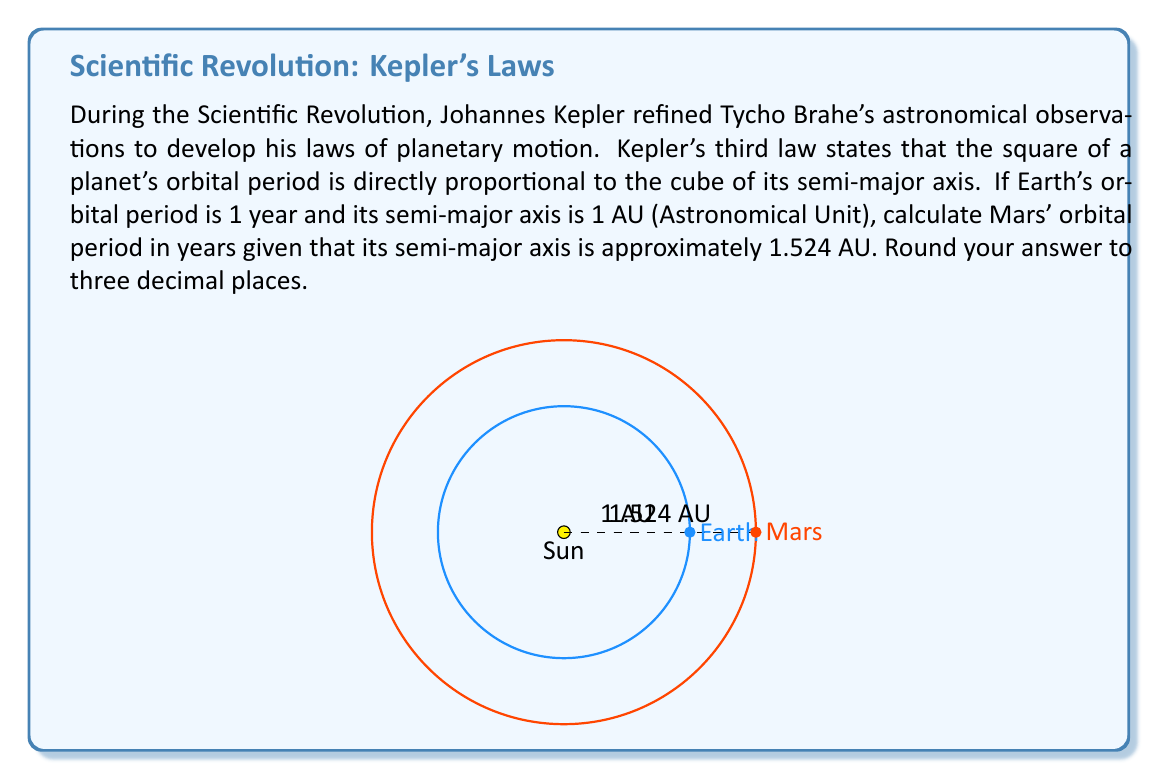Can you answer this question? Let's approach this step-by-step using Kepler's third law:

1) Kepler's third law states that $\frac{T^2}{a^3}$ is constant for all planets in a system, where $T$ is the orbital period and $a$ is the semi-major axis.

2) For Earth, we have:
   $T_E = 1$ year
   $a_E = 1$ AU

3) For Mars, we have:
   $a_M = 1.524$ AU
   $T_M$ is what we need to find

4) Using the law, we can set up the equation:
   $$\frac{T_E^2}{a_E^3} = \frac{T_M^2}{a_M^3}$$

5) Substituting the known values:
   $$\frac{1^2}{1^3} = \frac{T_M^2}{1.524^3}$$

6) Simplifying:
   $$1 = \frac{T_M^2}{3.54130824}$$

7) Multiplying both sides by 3.54130824:
   $$T_M^2 = 3.54130824$$

8) Taking the square root of both sides:
   $$T_M = \sqrt{3.54130824} \approx 1.88185$$

9) Rounding to three decimal places:
   $$T_M \approx 1.882$$ years

This demonstrates how improved mathematical precision during the Scientific Revolution allowed for more accurate predictions of planetary motion, a key advancement in astronomy during this period.
Answer: 1.882 years 